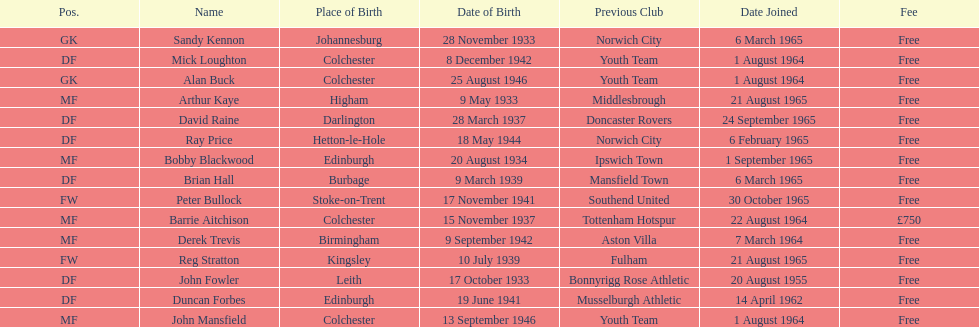What is the other fee listed, besides free? £750. 